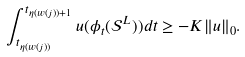<formula> <loc_0><loc_0><loc_500><loc_500>\int _ { t _ { \eta ( w ( j ) ) } } ^ { t _ { \eta ( w ( j ) ) + 1 } } u ( \phi _ { t } ( \mathcal { S } ^ { L } ) ) d t \geq - K \| u \| _ { 0 } .</formula> 